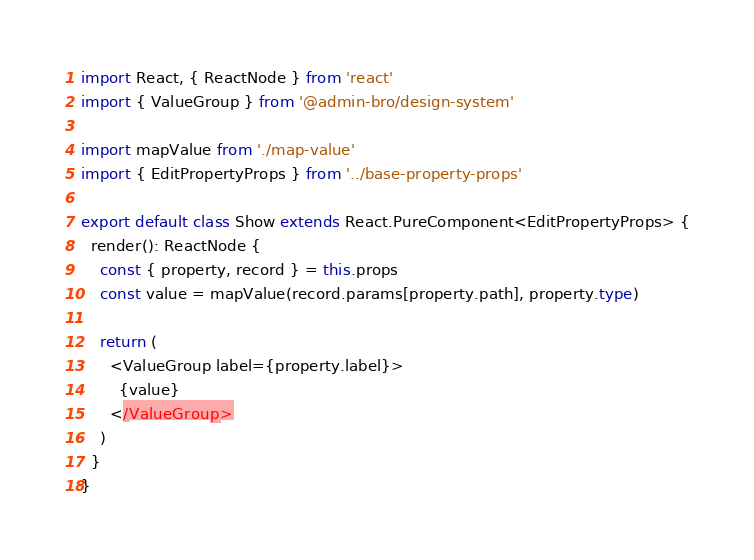<code> <loc_0><loc_0><loc_500><loc_500><_TypeScript_>import React, { ReactNode } from 'react'
import { ValueGroup } from '@admin-bro/design-system'

import mapValue from './map-value'
import { EditPropertyProps } from '../base-property-props'

export default class Show extends React.PureComponent<EditPropertyProps> {
  render(): ReactNode {
    const { property, record } = this.props
    const value = mapValue(record.params[property.path], property.type)

    return (
      <ValueGroup label={property.label}>
        {value}
      </ValueGroup>
    )
  }
}
</code> 